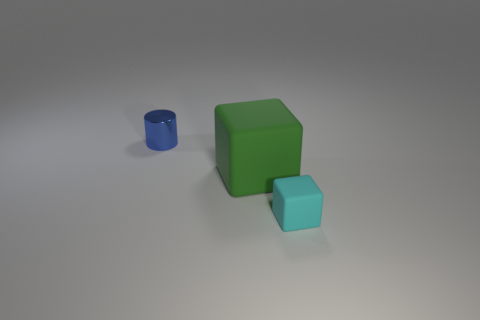What is the shape of the green object that is made of the same material as the cyan cube?
Your answer should be very brief. Cube. Is there anything else that has the same shape as the blue object?
Provide a succinct answer. No. Do the large green thing on the left side of the tiny matte thing and the tiny object behind the tiny rubber thing have the same material?
Give a very brief answer. No. The cylinder has what color?
Offer a very short reply. Blue. There is a matte thing behind the cube on the right side of the rubber object to the left of the tiny cyan block; what is its size?
Offer a very short reply. Large. How many other objects are there of the same size as the green rubber block?
Ensure brevity in your answer.  0. What number of big yellow cylinders are made of the same material as the tiny cyan cube?
Your response must be concise. 0. What shape is the rubber thing that is behind the small cyan thing?
Give a very brief answer. Cube. Do the big object and the small thing that is on the right side of the cylinder have the same material?
Offer a terse response. Yes. Are there any big matte cylinders?
Your answer should be very brief. No. 